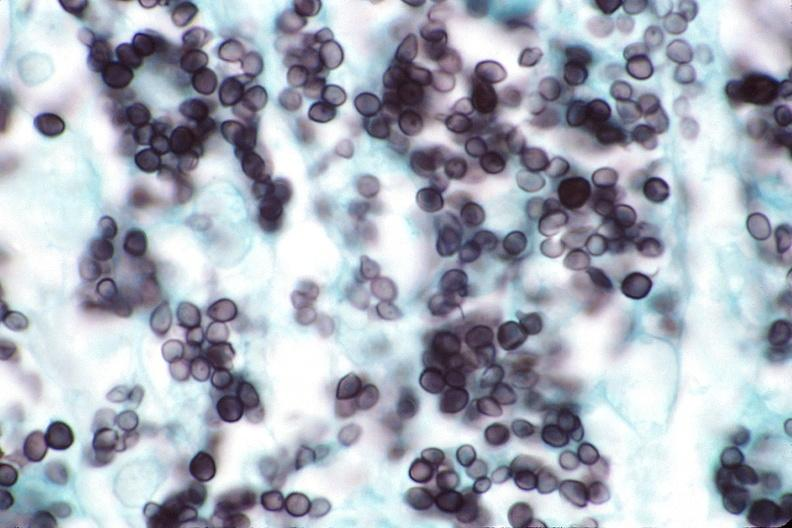do silver stain?
Answer the question using a single word or phrase. Yes 